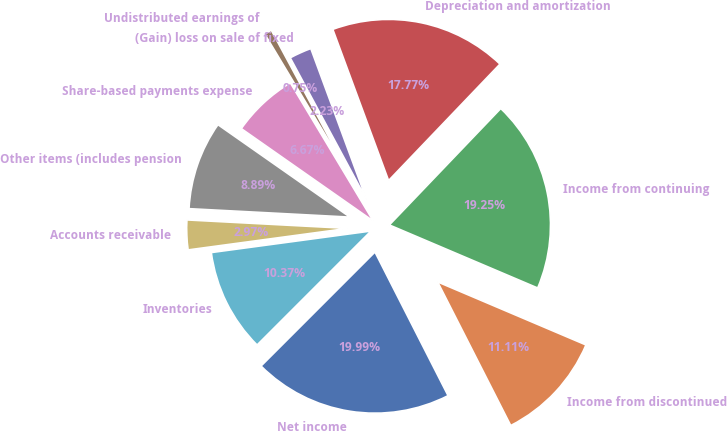<chart> <loc_0><loc_0><loc_500><loc_500><pie_chart><fcel>Net income<fcel>Income from discontinued<fcel>Income from continuing<fcel>Depreciation and amortization<fcel>(Gain) loss on sale of fixed<fcel>Undistributed earnings of<fcel>Share-based payments expense<fcel>Other items (includes pension<fcel>Accounts receivable<fcel>Inventories<nl><fcel>19.99%<fcel>11.11%<fcel>19.25%<fcel>17.77%<fcel>2.23%<fcel>0.75%<fcel>6.67%<fcel>8.89%<fcel>2.97%<fcel>10.37%<nl></chart> 